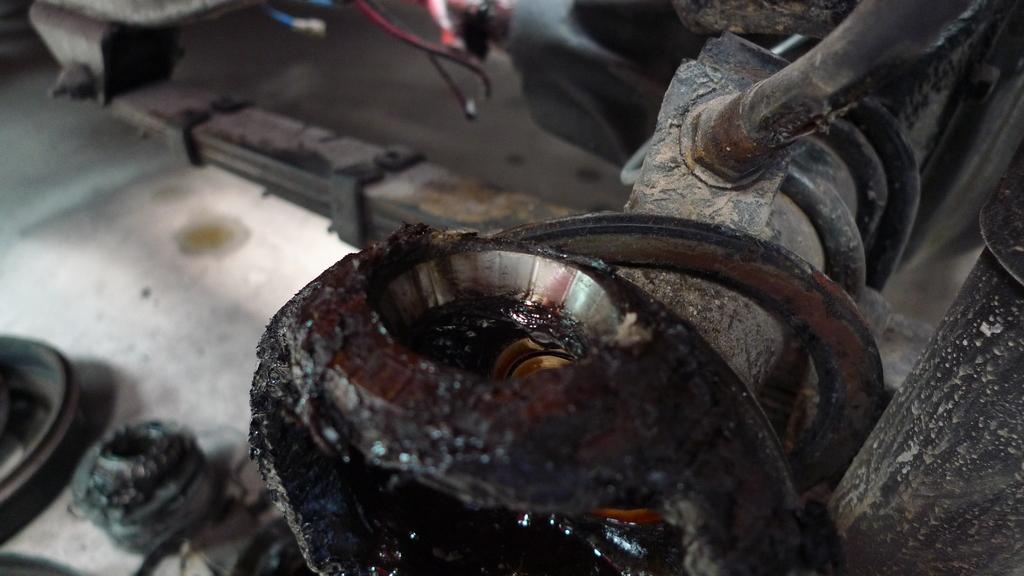Can you describe this image briefly? In the image we can see a under part of the vehicle. 